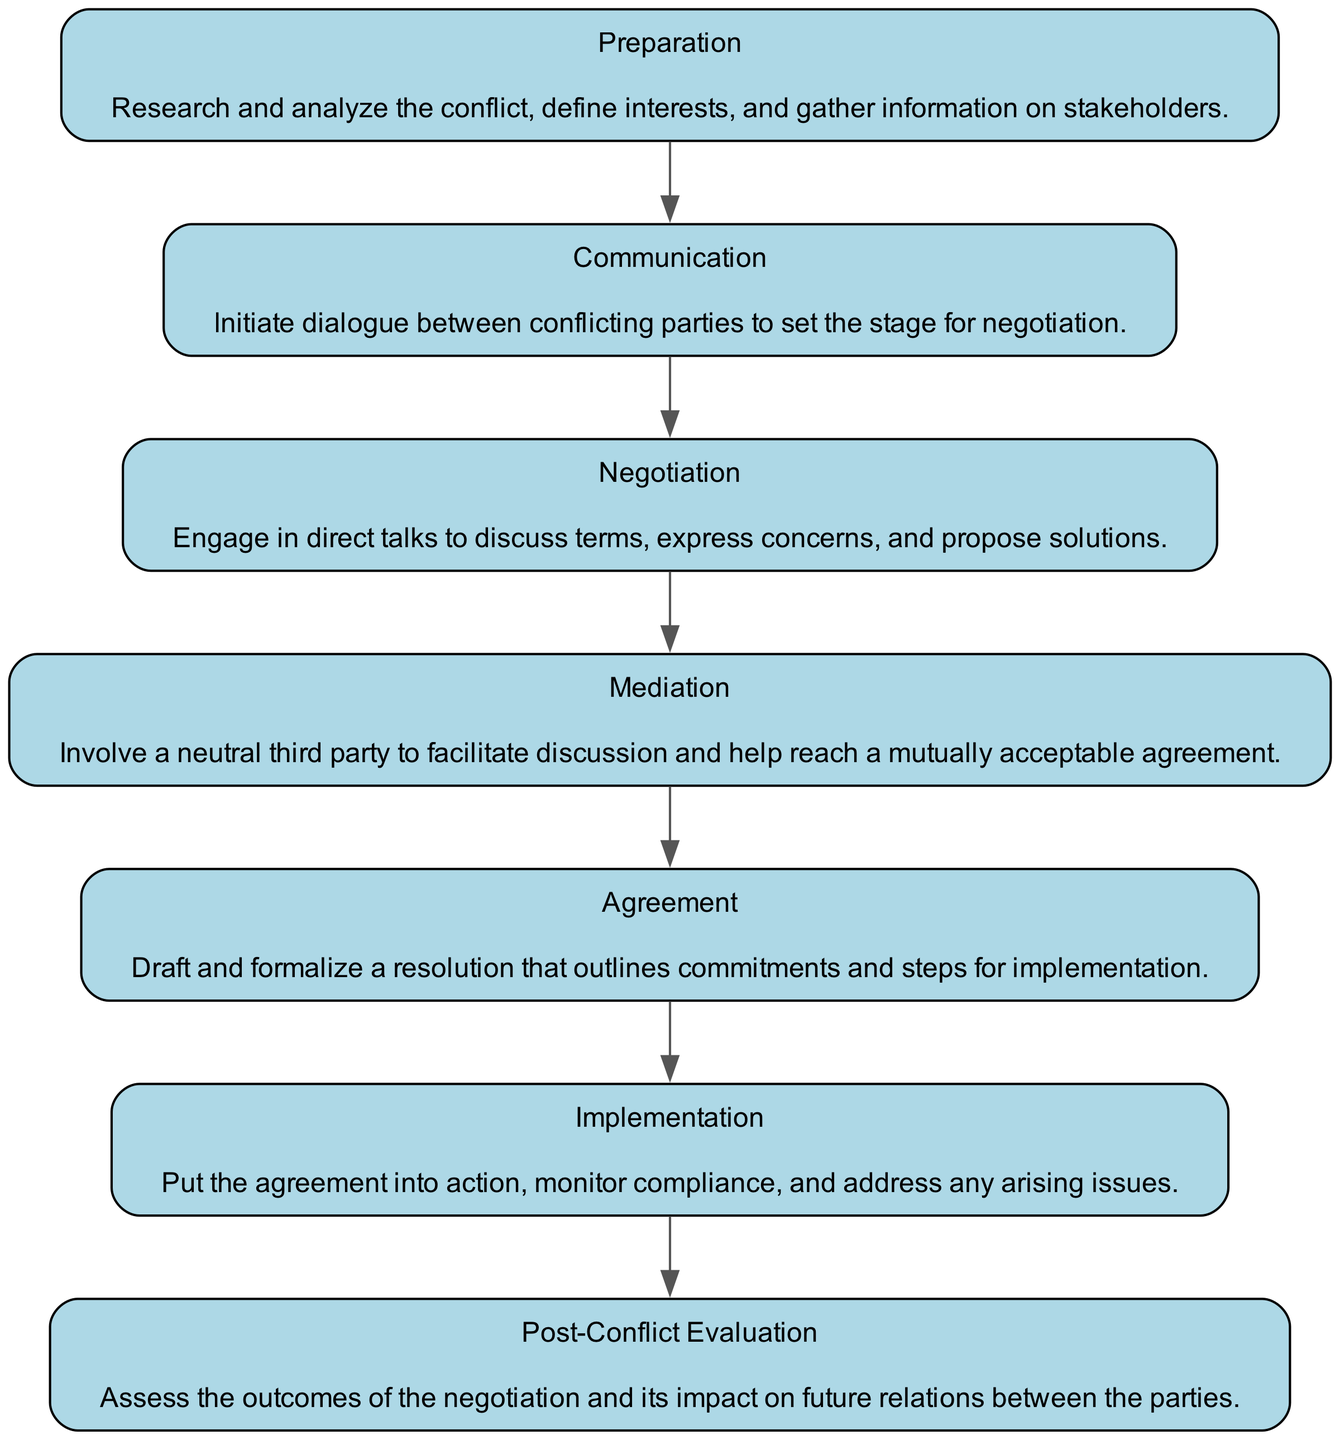What is the first stage of the negotiation process? The first stage in the flow chart is labeled "Preparation." This stage is indicated at the top of the chart as the starting point in the negotiation process.
Answer: Preparation How many stages are there in the diplomatic negotiation process? The diagram lists a total of seven distinct stages. By counting each of the labeled stages, we can determine that the total is seven.
Answer: Seven What stage comes after "Communication"? In the flow chart, "Negotiation" follows "Communication," as indicated by the directed arrow between these two stages.
Answer: Negotiation Which stage involves a neutral third party? The stage that involves a neutral third party is labeled "Mediation." This is specifically mentioned in the description of that stage in the diagram.
Answer: Mediation What is the immediate outcome expected from the "Agreement" stage? The immediate outcome expected from the "Agreement" stage is a resolution that outlines commitments and steps for implementation. This is directly mentioned in the description of the "Agreement" stage within the flow chart.
Answer: Resolution What are the last two stages of the negotiation process? The last two stages in the flow chart are "Implementation" and "Post-Conflict Evaluation." They appear towards the bottom of the diagram, indicating the concluding steps of the entire negotiation process.
Answer: Implementation and Post-Conflict Evaluation Which stage is directly before "Mediation"? The stage directly before "Mediation" is "Negotiation." The chart shows an arrow leading from "Negotiation" to "Mediation," indicating the sequence.
Answer: Negotiation What does the "Preparation" stage entail? The "Preparation" stage involves researching and analyzing the conflict, defining interests, and gathering information on stakeholders. This description provides details about the activities in this initial stage of negotiation.
Answer: Research and analyze the conflict, define interests, and gather information on stakeholders 